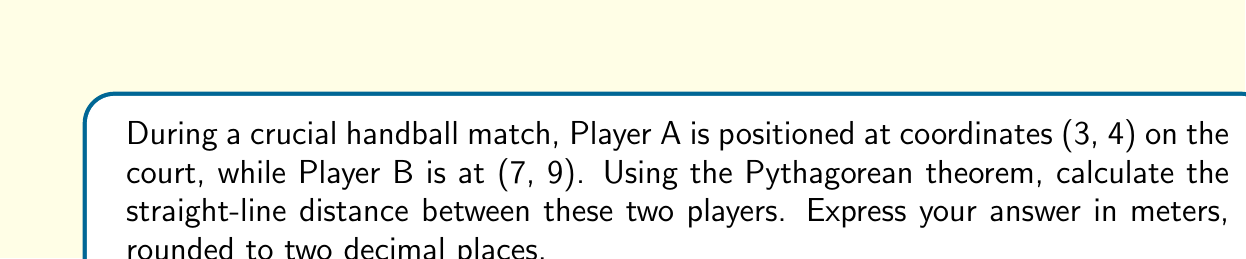Solve this math problem. To find the distance between two points on a coordinate plane, we can use the distance formula, which is derived from the Pythagorean theorem:

$$d = \sqrt{(x_2-x_1)^2 + (y_2-y_1)^2}$$

Where $(x_1, y_1)$ are the coordinates of the first point and $(x_2, y_2)$ are the coordinates of the second point.

Step 1: Identify the coordinates
Player A: $(x_1, y_1) = (3, 4)$
Player B: $(x_2, y_2) = (7, 9)$

Step 2: Plug the coordinates into the distance formula
$$d = \sqrt{(7-3)^2 + (9-4)^2}$$

Step 3: Simplify the expressions inside the parentheses
$$d = \sqrt{4^2 + 5^2}$$

Step 4: Calculate the squares
$$d = \sqrt{16 + 25}$$

Step 5: Add the numbers under the square root
$$d = \sqrt{41}$$

Step 6: Calculate the square root and round to two decimal places
$$d \approx 6.40$$

Therefore, the distance between Player A and Player B is approximately 6.40 meters.
Answer: 6.40 meters 